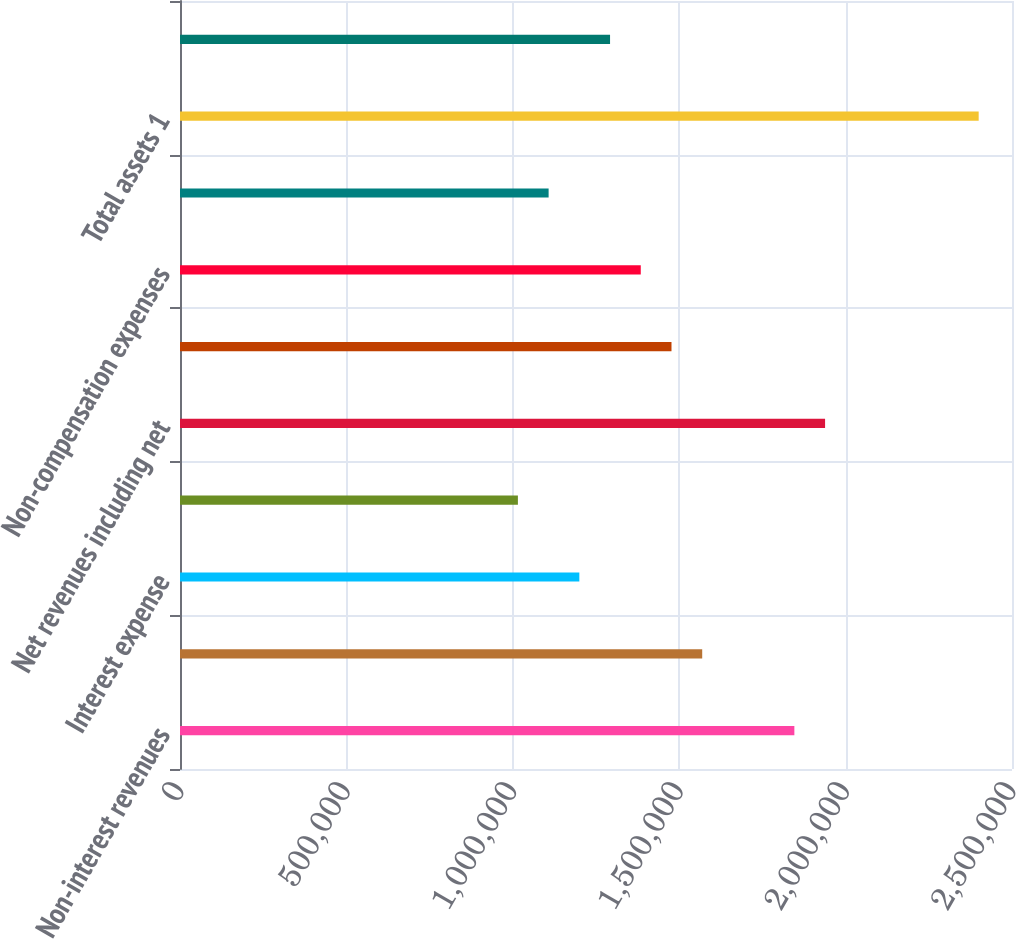<chart> <loc_0><loc_0><loc_500><loc_500><bar_chart><fcel>Non-interest revenues<fcel>Interest income<fcel>Interest expense<fcel>Net interest income<fcel>Net revenues including net<fcel>Compensation and benefits<fcel>Non-compensation expenses<fcel>Pre-tax earnings<fcel>Total assets 1<fcel>Other secured financings<nl><fcel>1.84604e+06<fcel>1.56914e+06<fcel>1.19993e+06<fcel>1.01532e+06<fcel>1.93834e+06<fcel>1.47683e+06<fcel>1.38453e+06<fcel>1.10763e+06<fcel>2.39985e+06<fcel>1.29223e+06<nl></chart> 